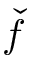<formula> <loc_0><loc_0><loc_500><loc_500>\ w i d e c h e c k { f }</formula> 